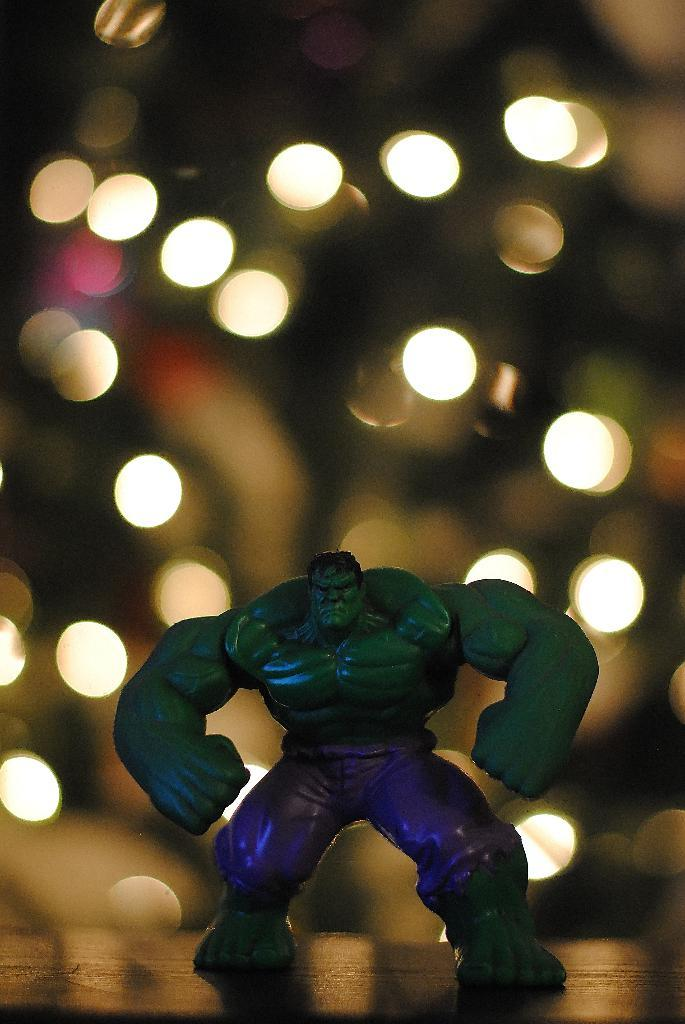What toy is on the table in the image? There is a hulk toy on the table. What can be seen in the background of the image? There are lights in the background of the image. What type of soap is being used to clean the wrench in the image? There is no soap or wrench present in the image; it only features a hulk toy on the table and lights in the background. 